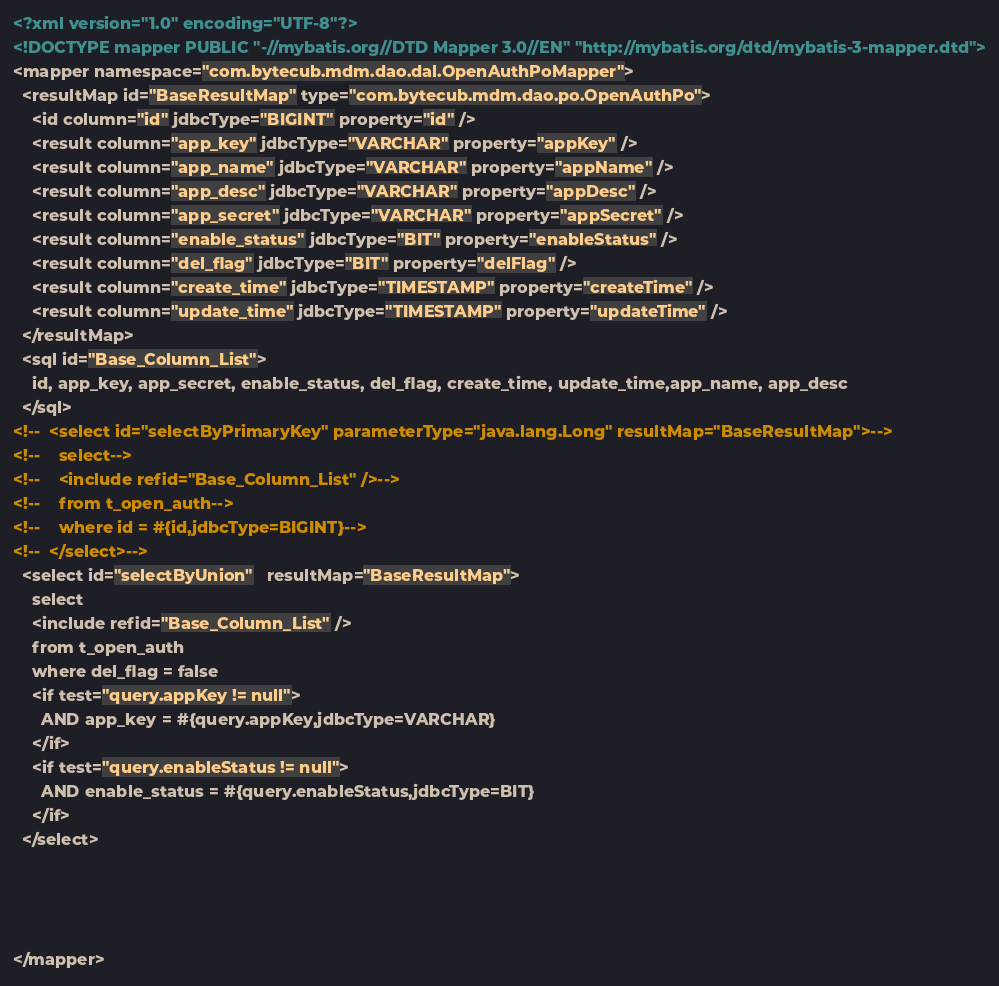Convert code to text. <code><loc_0><loc_0><loc_500><loc_500><_XML_><?xml version="1.0" encoding="UTF-8"?>
<!DOCTYPE mapper PUBLIC "-//mybatis.org//DTD Mapper 3.0//EN" "http://mybatis.org/dtd/mybatis-3-mapper.dtd">
<mapper namespace="com.bytecub.mdm.dao.dal.OpenAuthPoMapper">
  <resultMap id="BaseResultMap" type="com.bytecub.mdm.dao.po.OpenAuthPo">
    <id column="id" jdbcType="BIGINT" property="id" />
    <result column="app_key" jdbcType="VARCHAR" property="appKey" />
    <result column="app_name" jdbcType="VARCHAR" property="appName" />
    <result column="app_desc" jdbcType="VARCHAR" property="appDesc" />
    <result column="app_secret" jdbcType="VARCHAR" property="appSecret" />
    <result column="enable_status" jdbcType="BIT" property="enableStatus" />
    <result column="del_flag" jdbcType="BIT" property="delFlag" />
    <result column="create_time" jdbcType="TIMESTAMP" property="createTime" />
    <result column="update_time" jdbcType="TIMESTAMP" property="updateTime" />
  </resultMap>
  <sql id="Base_Column_List">
    id, app_key, app_secret, enable_status, del_flag, create_time, update_time,app_name, app_desc
  </sql>
<!--  <select id="selectByPrimaryKey" parameterType="java.lang.Long" resultMap="BaseResultMap">-->
<!--    select-->
<!--    <include refid="Base_Column_List" />-->
<!--    from t_open_auth-->
<!--    where id = #{id,jdbcType=BIGINT}-->
<!--  </select>-->
  <select id="selectByUnion"   resultMap="BaseResultMap">
    select
    <include refid="Base_Column_List" />
    from t_open_auth
    where del_flag = false
    <if test="query.appKey != null">
      AND app_key = #{query.appKey,jdbcType=VARCHAR}
    </if>
    <if test="query.enableStatus != null">
      AND enable_status = #{query.enableStatus,jdbcType=BIT}
    </if>
  </select>




</mapper>
</code> 